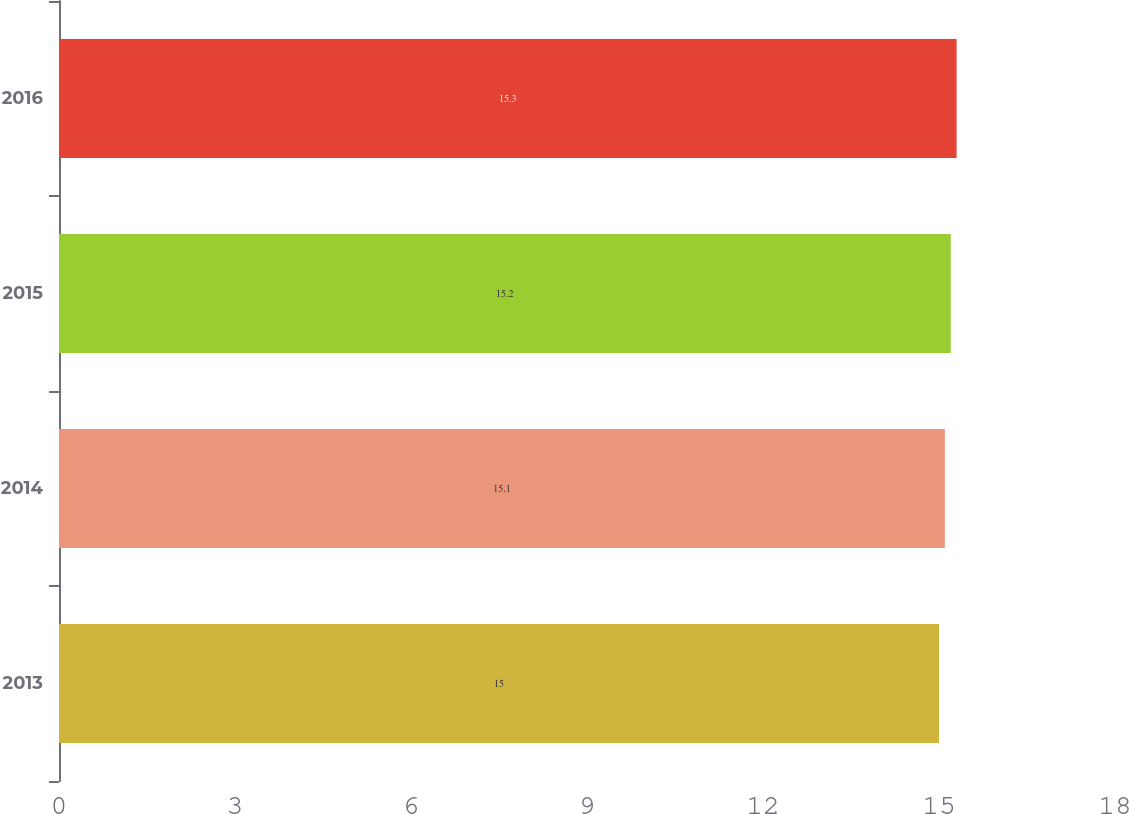Convert chart to OTSL. <chart><loc_0><loc_0><loc_500><loc_500><bar_chart><fcel>2013<fcel>2014<fcel>2015<fcel>2016<nl><fcel>15<fcel>15.1<fcel>15.2<fcel>15.3<nl></chart> 